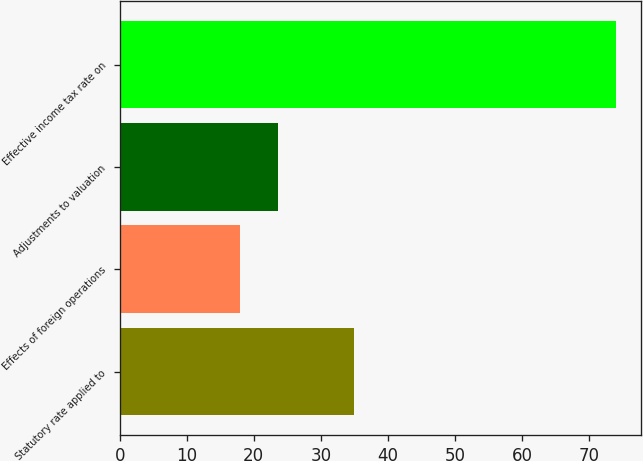Convert chart. <chart><loc_0><loc_0><loc_500><loc_500><bar_chart><fcel>Statutory rate applied to<fcel>Effects of foreign operations<fcel>Adjustments to valuation<fcel>Effective income tax rate on<nl><fcel>35<fcel>18<fcel>23.6<fcel>74<nl></chart> 